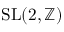Convert formula to latex. <formula><loc_0><loc_0><loc_500><loc_500>S L ( 2 , \mathbb { Z } )</formula> 